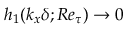<formula> <loc_0><loc_0><loc_500><loc_500>h _ { 1 } ( k _ { x } \delta ; R e _ { \tau } ) \rightarrow 0</formula> 